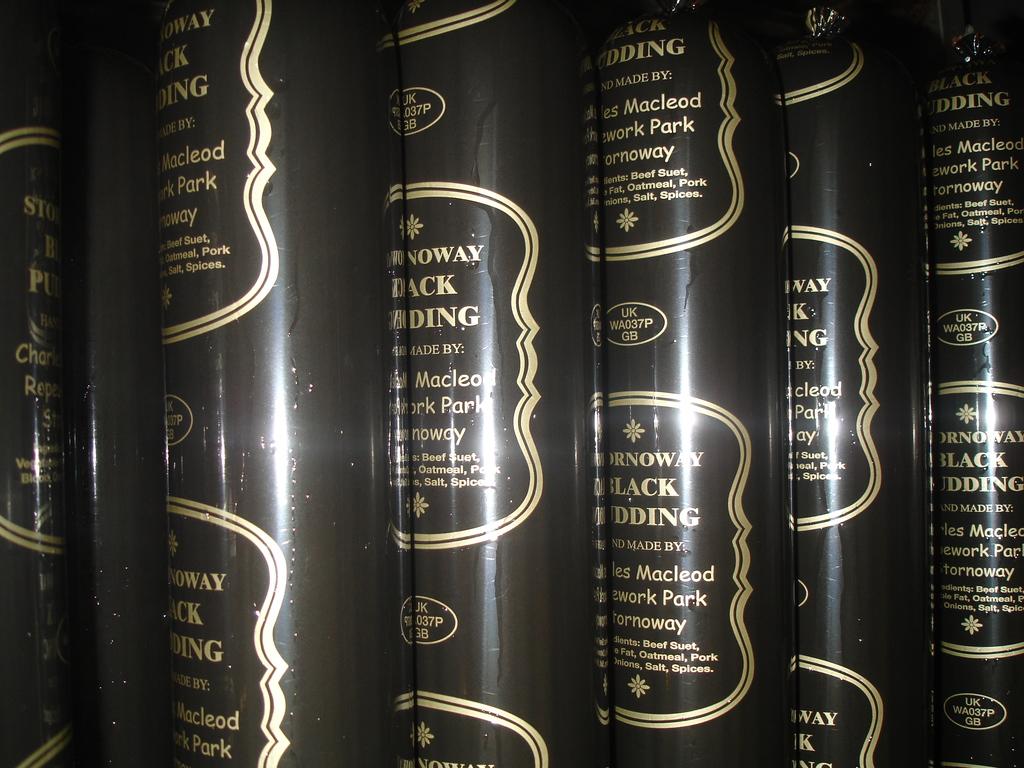What is the first name of the author?
Offer a very short reply. Unanswerable. 